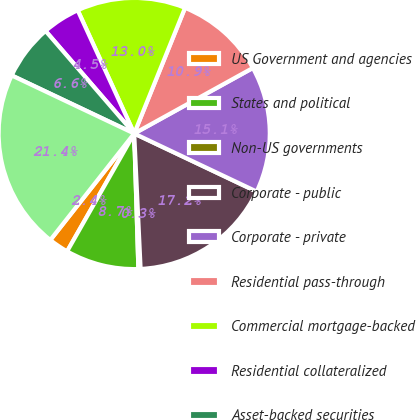Convert chart to OTSL. <chart><loc_0><loc_0><loc_500><loc_500><pie_chart><fcel>US Government and agencies<fcel>States and political<fcel>Non-US governments<fcel>Corporate - public<fcel>Corporate - private<fcel>Residential pass-through<fcel>Commercial mortgage-backed<fcel>Residential collateralized<fcel>Asset-backed securities<fcel>Total fixed maturity<nl><fcel>2.38%<fcel>8.73%<fcel>0.26%<fcel>17.2%<fcel>15.08%<fcel>10.85%<fcel>12.96%<fcel>4.5%<fcel>6.61%<fcel>21.43%<nl></chart> 